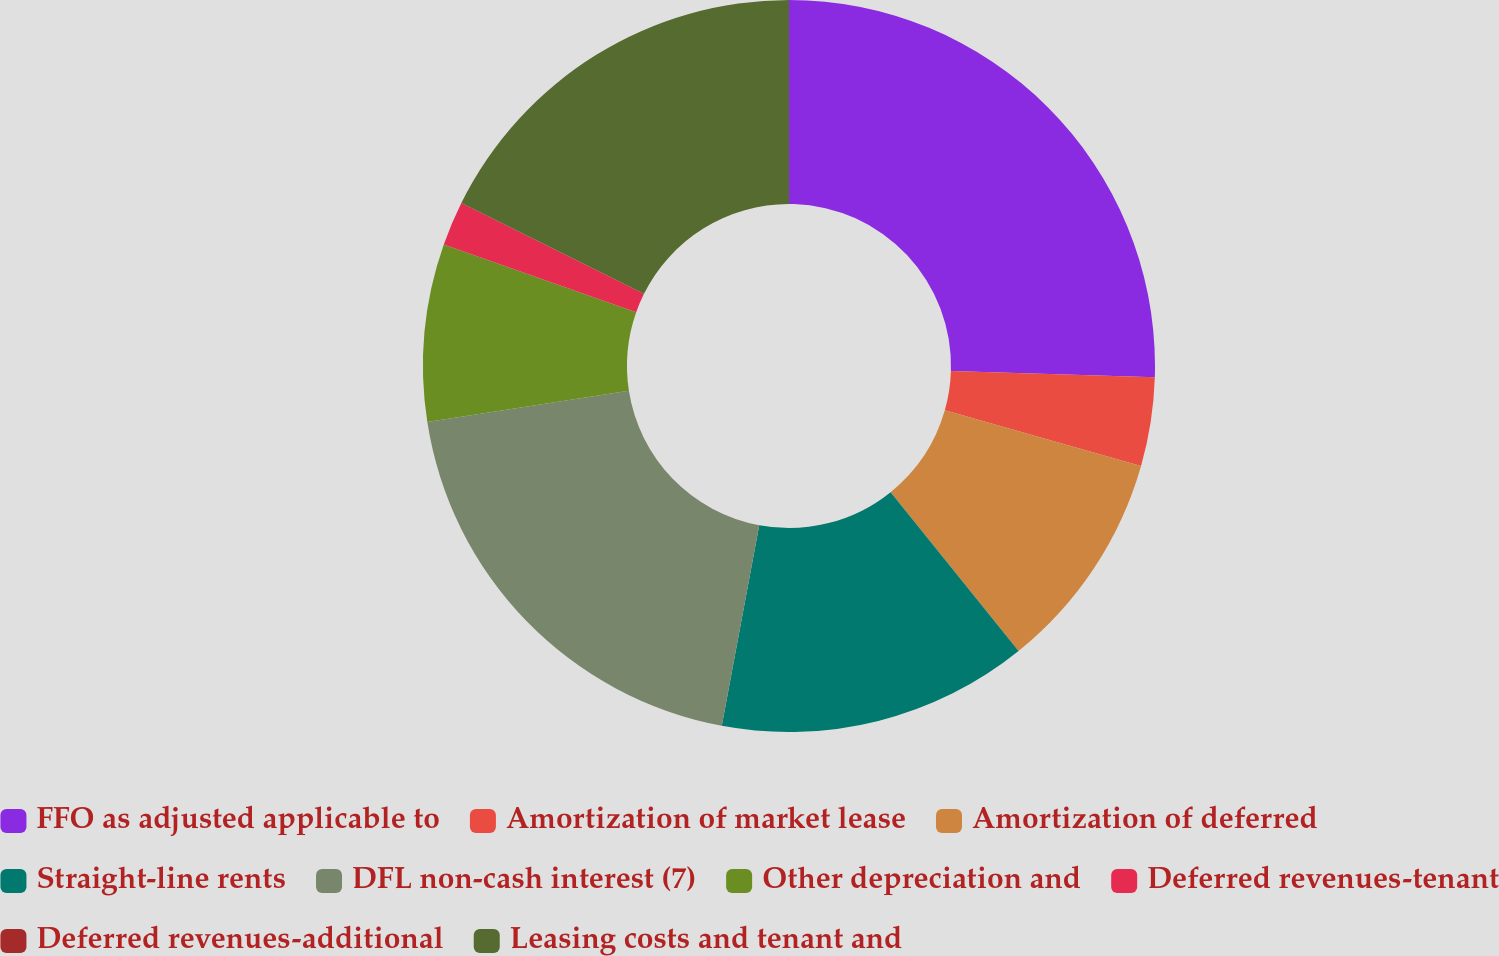Convert chart to OTSL. <chart><loc_0><loc_0><loc_500><loc_500><pie_chart><fcel>FFO as adjusted applicable to<fcel>Amortization of market lease<fcel>Amortization of deferred<fcel>Straight-line rents<fcel>DFL non-cash interest (7)<fcel>Other depreciation and<fcel>Deferred revenues-tenant<fcel>Deferred revenues-additional<fcel>Leasing costs and tenant and<nl><fcel>25.49%<fcel>3.92%<fcel>9.8%<fcel>13.73%<fcel>19.61%<fcel>7.84%<fcel>1.96%<fcel>0.0%<fcel>17.65%<nl></chart> 